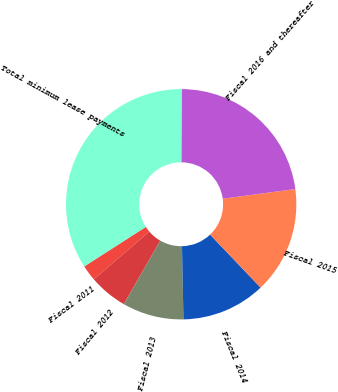Convert chart to OTSL. <chart><loc_0><loc_0><loc_500><loc_500><pie_chart><fcel>Fiscal 2011<fcel>Fiscal 2012<fcel>Fiscal 2013<fcel>Fiscal 2014<fcel>Fiscal 2015<fcel>Fiscal 2016 and thereafter<fcel>Total minimum lease payments<nl><fcel>2.22%<fcel>5.41%<fcel>8.61%<fcel>11.8%<fcel>14.99%<fcel>22.83%<fcel>34.14%<nl></chart> 